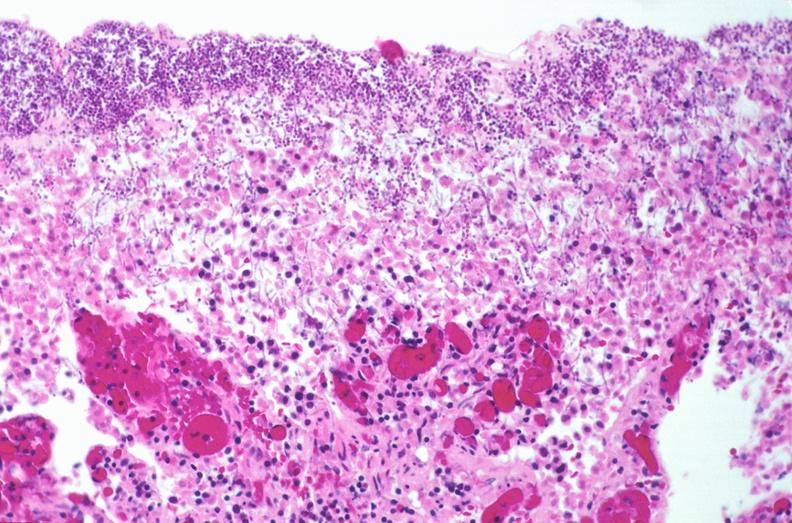what is present?
Answer the question using a single word or phrase. Gastrointestinal 